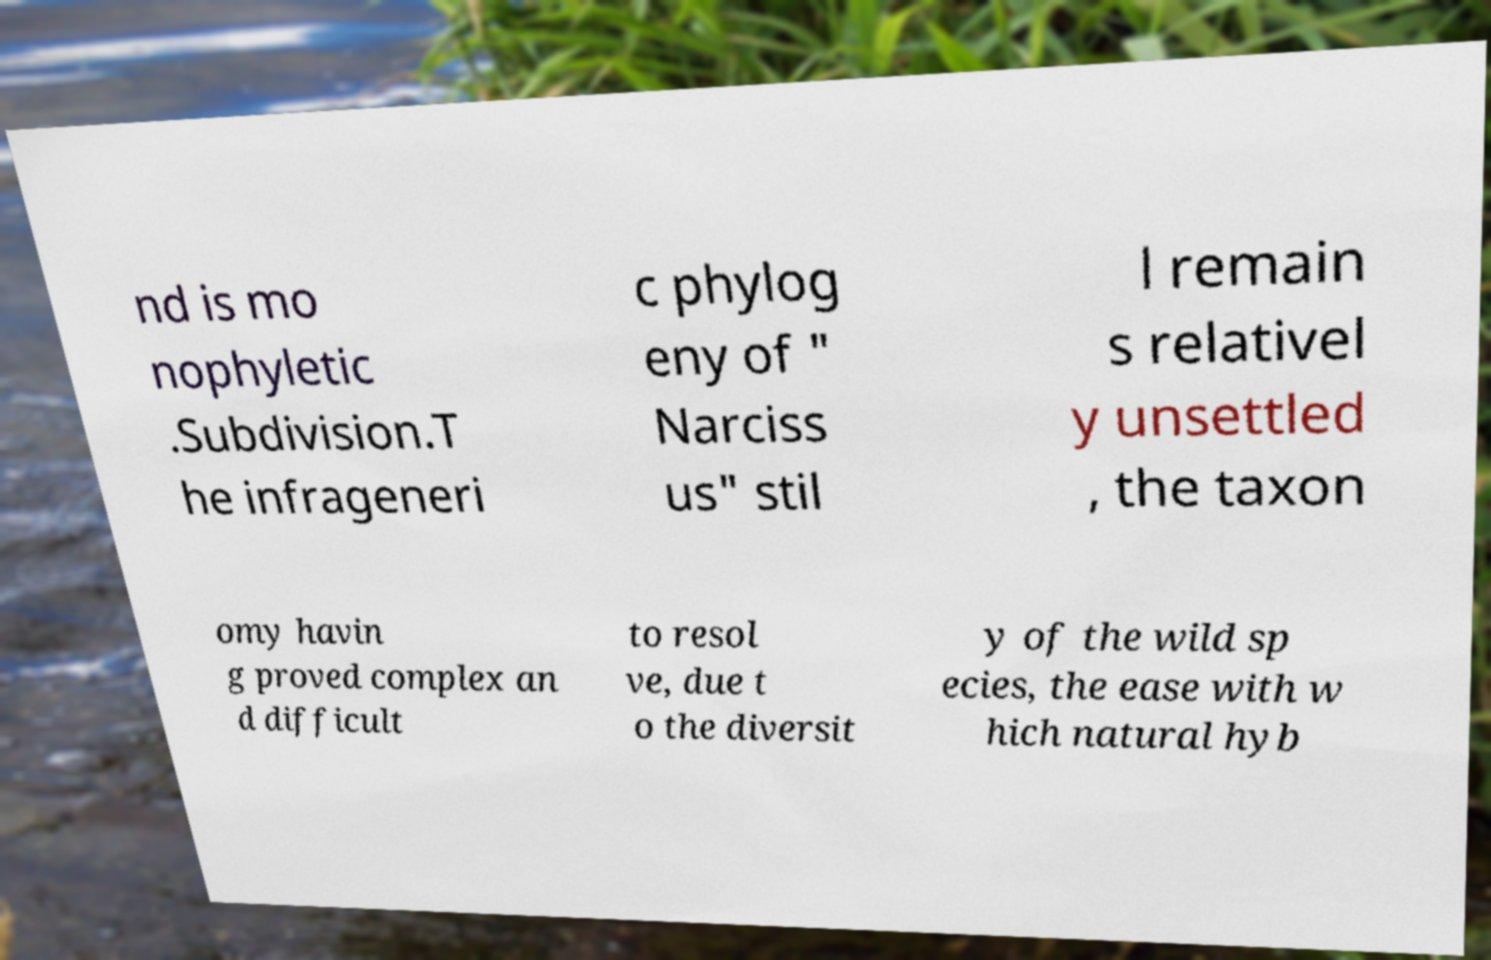Could you extract and type out the text from this image? nd is mo nophyletic .Subdivision.T he infrageneri c phylog eny of " Narciss us" stil l remain s relativel y unsettled , the taxon omy havin g proved complex an d difficult to resol ve, due t o the diversit y of the wild sp ecies, the ease with w hich natural hyb 